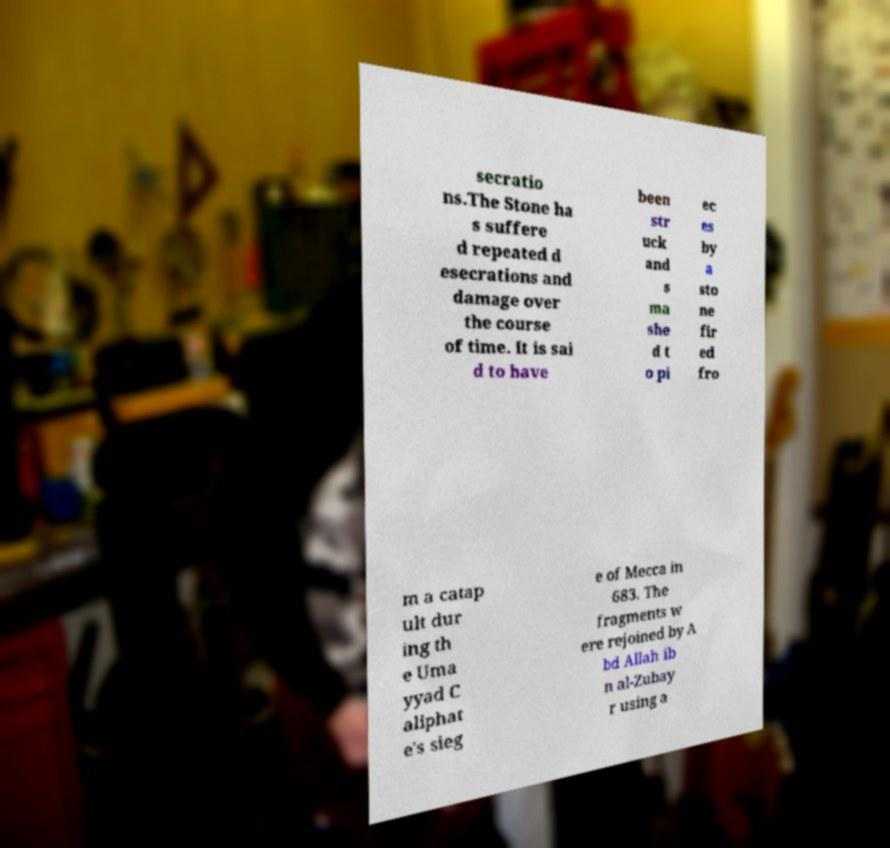Could you assist in decoding the text presented in this image and type it out clearly? secratio ns.The Stone ha s suffere d repeated d esecrations and damage over the course of time. It is sai d to have been str uck and s ma she d t o pi ec es by a sto ne fir ed fro m a catap ult dur ing th e Uma yyad C aliphat e's sieg e of Mecca in 683. The fragments w ere rejoined by A bd Allah ib n al-Zubay r using a 